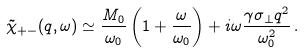Convert formula to latex. <formula><loc_0><loc_0><loc_500><loc_500>\tilde { \chi } _ { + - } ( q , \omega ) \simeq \frac { M _ { 0 } } { \omega _ { 0 } } \left ( 1 + \frac { \omega } { \omega _ { 0 } } \right ) + i \omega \frac { \gamma \sigma _ { \perp } q ^ { 2 } } { \omega _ { 0 } ^ { 2 } } \, .</formula> 